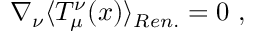Convert formula to latex. <formula><loc_0><loc_0><loc_500><loc_500>\nabla _ { \nu } \langle T _ { \mu } ^ { \nu } ( x ) \rangle _ { R e n . } = 0 \ ,</formula> 